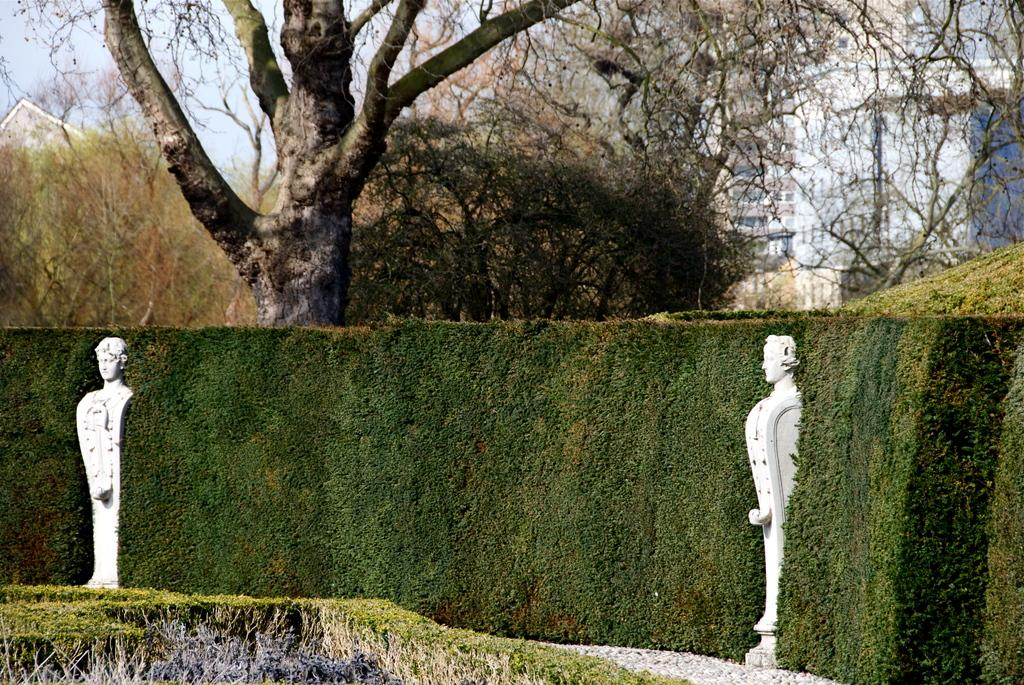How many statues are present in the image? There are two statues in the image. What type of vegetation can be seen in the image? There is grass and trees in the image. What type of structures are visible in the image? There are buildings in the image. What can be seen in the background of the image? The sky is visible in the background of the image. What color is the sweater worn by the mother in the image? There is no mother or sweater present in the image. 